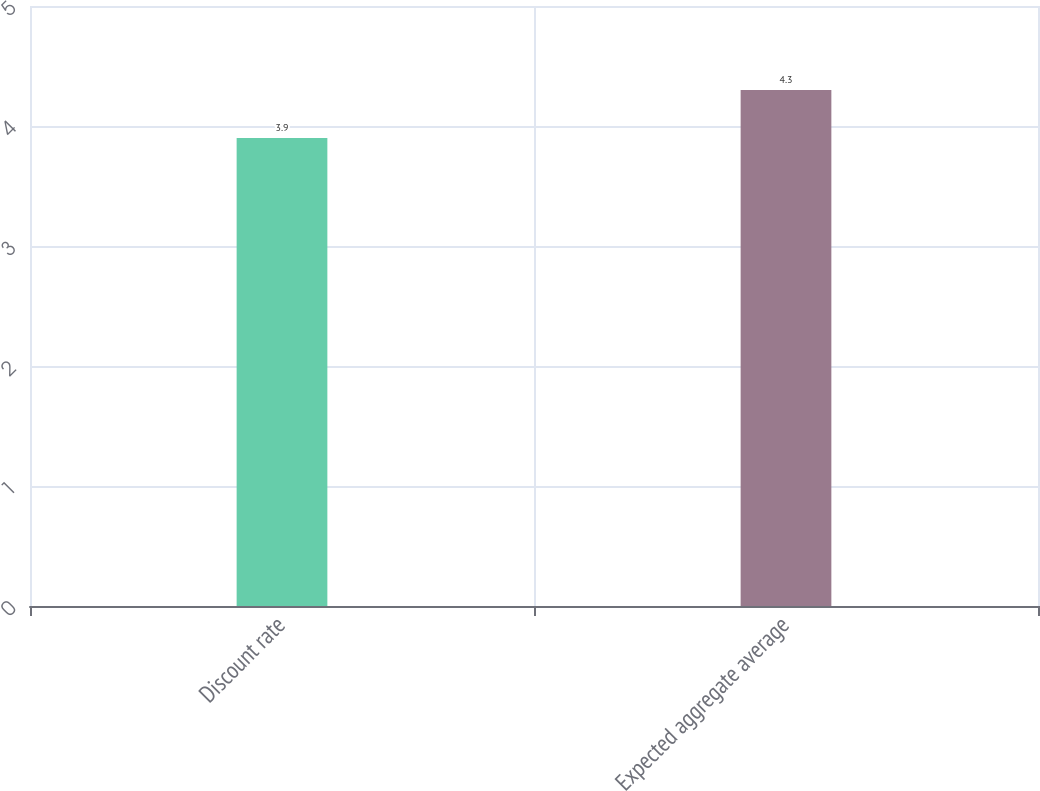Convert chart. <chart><loc_0><loc_0><loc_500><loc_500><bar_chart><fcel>Discount rate<fcel>Expected aggregate average<nl><fcel>3.9<fcel>4.3<nl></chart> 